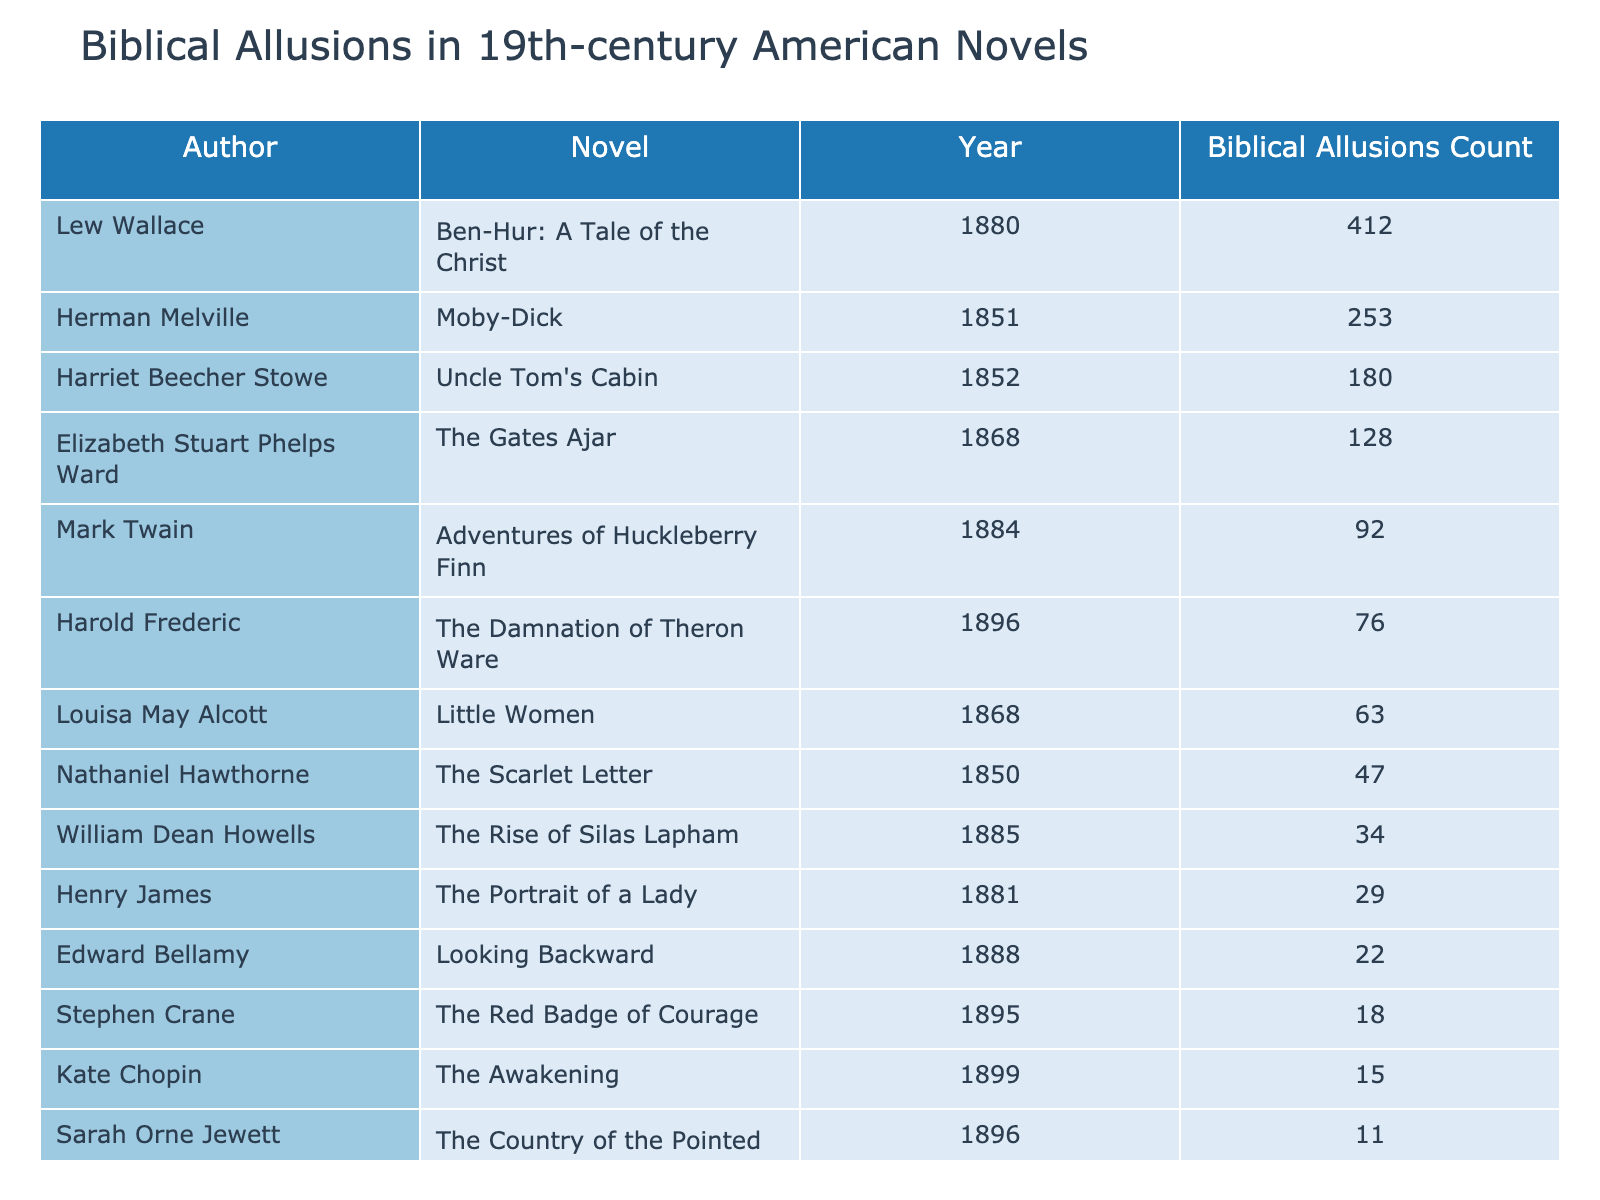What is the novel by Lew Wallace that contains the highest number of biblical allusions? The table indicates that Lew Wallace's novel "Ben-Hur: A Tale of the Christ" has a biblical allusions count of 412, which is the highest among all listed works.
Answer: Ben-Hur: A Tale of the Christ Which author wrote "The Scarlet Letter" and how many biblical allusions does it contain? "The Scarlet Letter" is authored by Nathaniel Hawthorne, and it contains 47 biblical allusions as per the table.
Answer: Nathaniel Hawthorne, 47 What is the average number of biblical allusions across all listed novels? To find the average, sum all the biblical allusions: 47 + 253 + 180 + 92 + 63 + 29 + 18 + 15 + 34 + 76 + 128 + 412 + 22 + 11 + 8 = 1,095. There are 15 works, so the average is 1,095 / 15 = 73.
Answer: 73 Which novel has the least number of biblical allusions, and how many does it have? The table shows that "McTeague" by Frank Norris has the least number of biblical allusions, which is 8.
Answer: McTeague, 8 Is there a novel by a female author that contains more than 100 biblical allusions? Yes, "Uncle Tom's Cabin" by Harriet Beecher Stowe has 180 biblical allusions, which exceeds 100.
Answer: Yes How many more biblical allusions does "Moby-Dick" have compared to "The Red Badge of Courage"? "Moby-Dick" has 253 allusions while "The Red Badge of Courage" has 18, so the difference is 253 - 18 = 235.
Answer: 235 Are there any novels from the 1860s with fewer than 50 biblical allusions? Yes, Louisa May Alcott's "Little Women" from 1868 has 63 biblical allusions, which is not fewer than 50, but "The Gates Ajar" by Elizabeth Stuart Phelps Ward also from 1868 contains 128 allusions, so there are no novels from this decade with fewer than 50.
Answer: No Which author has the highest total count of biblical allusions across their novels in this list? The table indicates that Lew Wallace has the highest total, with "Ben-Hur" alone having 412, while the next highest is Melville with 253 from "Moby-Dick."
Answer: Lew Wallace How many biblical allusions do the works of Stephen Crane and Kate Chopin combined total? "The Red Badge of Courage" by Stephen Crane has 18 allusions and "The Awakening" by Kate Chopin has 15, so their combined total is 18 + 15 = 33.
Answer: 33 Is the number of biblical allusions in "The Portrait of a Lady" greater than that in "Adventures of Huckleberry Finn"? "The Portrait of a Lady" contains 29 biblical allusions, while "Adventures of Huckleberry Finn" has 92, so the former is not greater than the latter.
Answer: No 